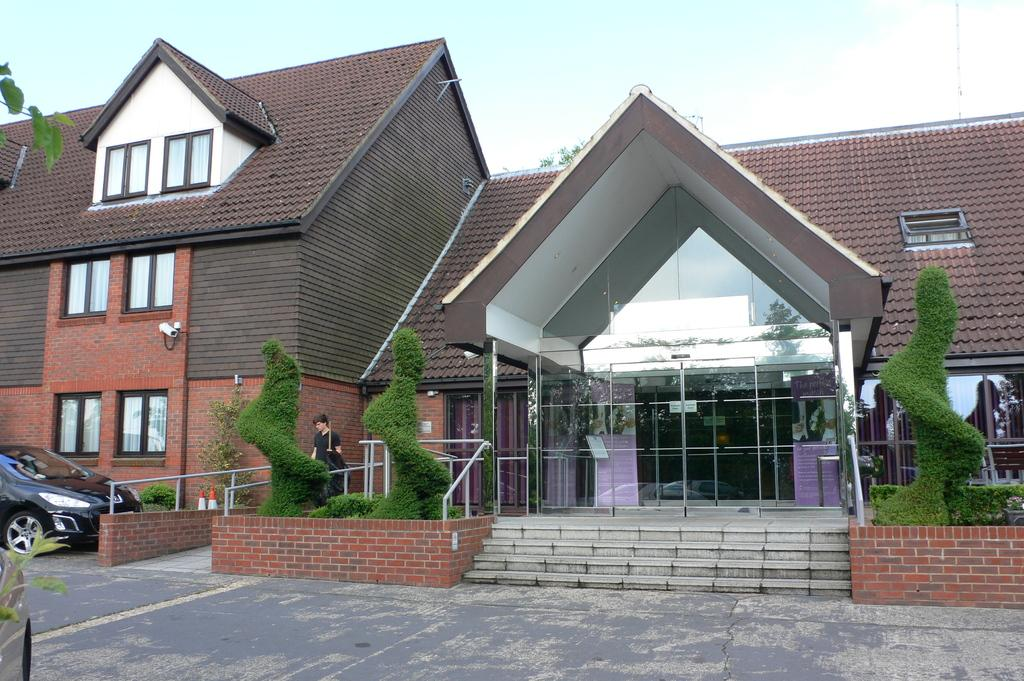What type of structure is visible in the image? There is a building in the image. What else can be seen in the image besides the building? There are plants and a car parked in the image. What is the human in the image holding? The human is holding a stick in the image. How would you describe the sky in the image? The sky is blue and cloudy in the image. What type of wire is being used to connect the wax to the plot in the image? There is no wax, plot, or wire present in the image. 